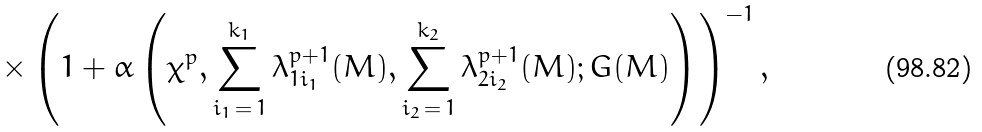<formula> <loc_0><loc_0><loc_500><loc_500>\times \left ( 1 + \alpha \left ( \chi ^ { p } , \sum _ { i _ { 1 } \, = \, 1 } ^ { k _ { 1 } } \lambda _ { 1 i _ { 1 } } ^ { p + 1 } ( M ) , \sum _ { i _ { 2 } \, = \, 1 } ^ { k _ { 2 } } \lambda _ { 2 i _ { 2 } } ^ { p + 1 } ( M ) ; G ( M ) \right ) \right ) ^ { - 1 } ,</formula> 